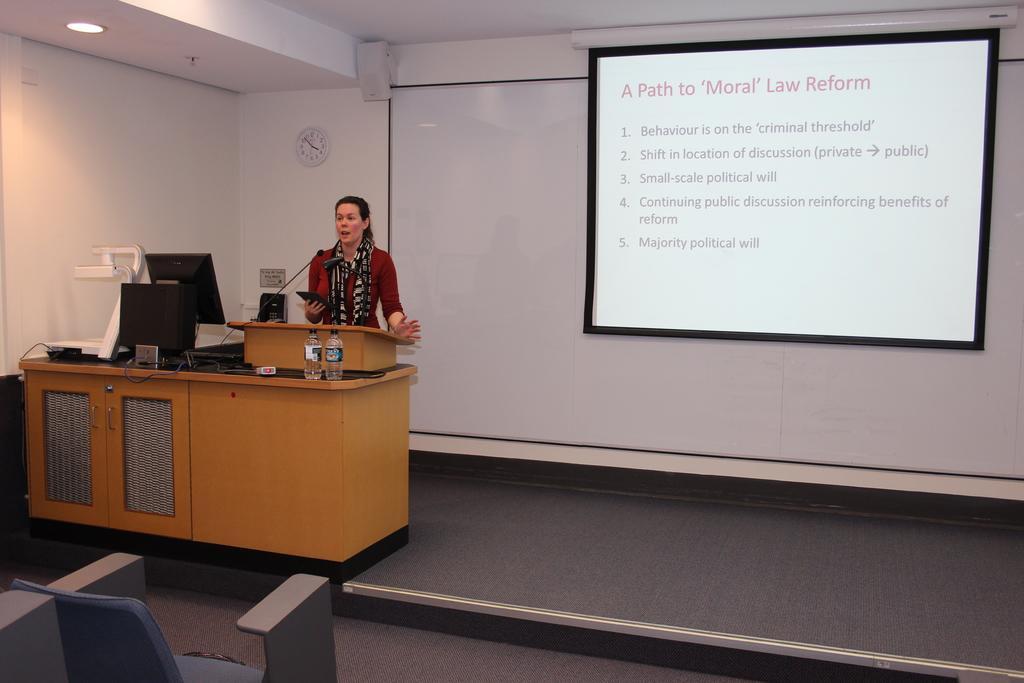In one or two sentences, can you explain what this image depicts? In this image, we can see a person wearing clothes and standing in front of the podium. There are monitors and bottles on the table which is on the left side of the image. There is a screen in the top right of the image. There is a light in the top left of the image. There is a chair in the bottom left of the image. 